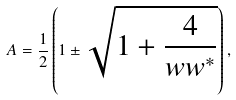<formula> <loc_0><loc_0><loc_500><loc_500>A = \frac { 1 } { 2 } \left ( 1 \pm \sqrt { 1 + \frac { 4 } { w w ^ { * } } } \right ) ,</formula> 